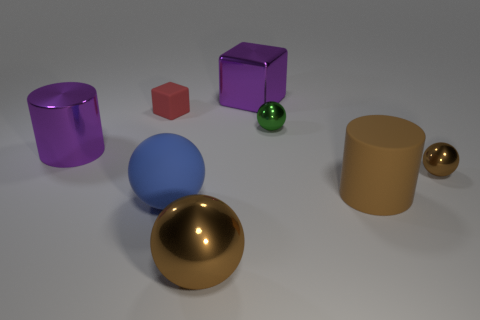What number of small green spheres are behind the blue sphere that is in front of the tiny sphere behind the tiny brown thing? 1 